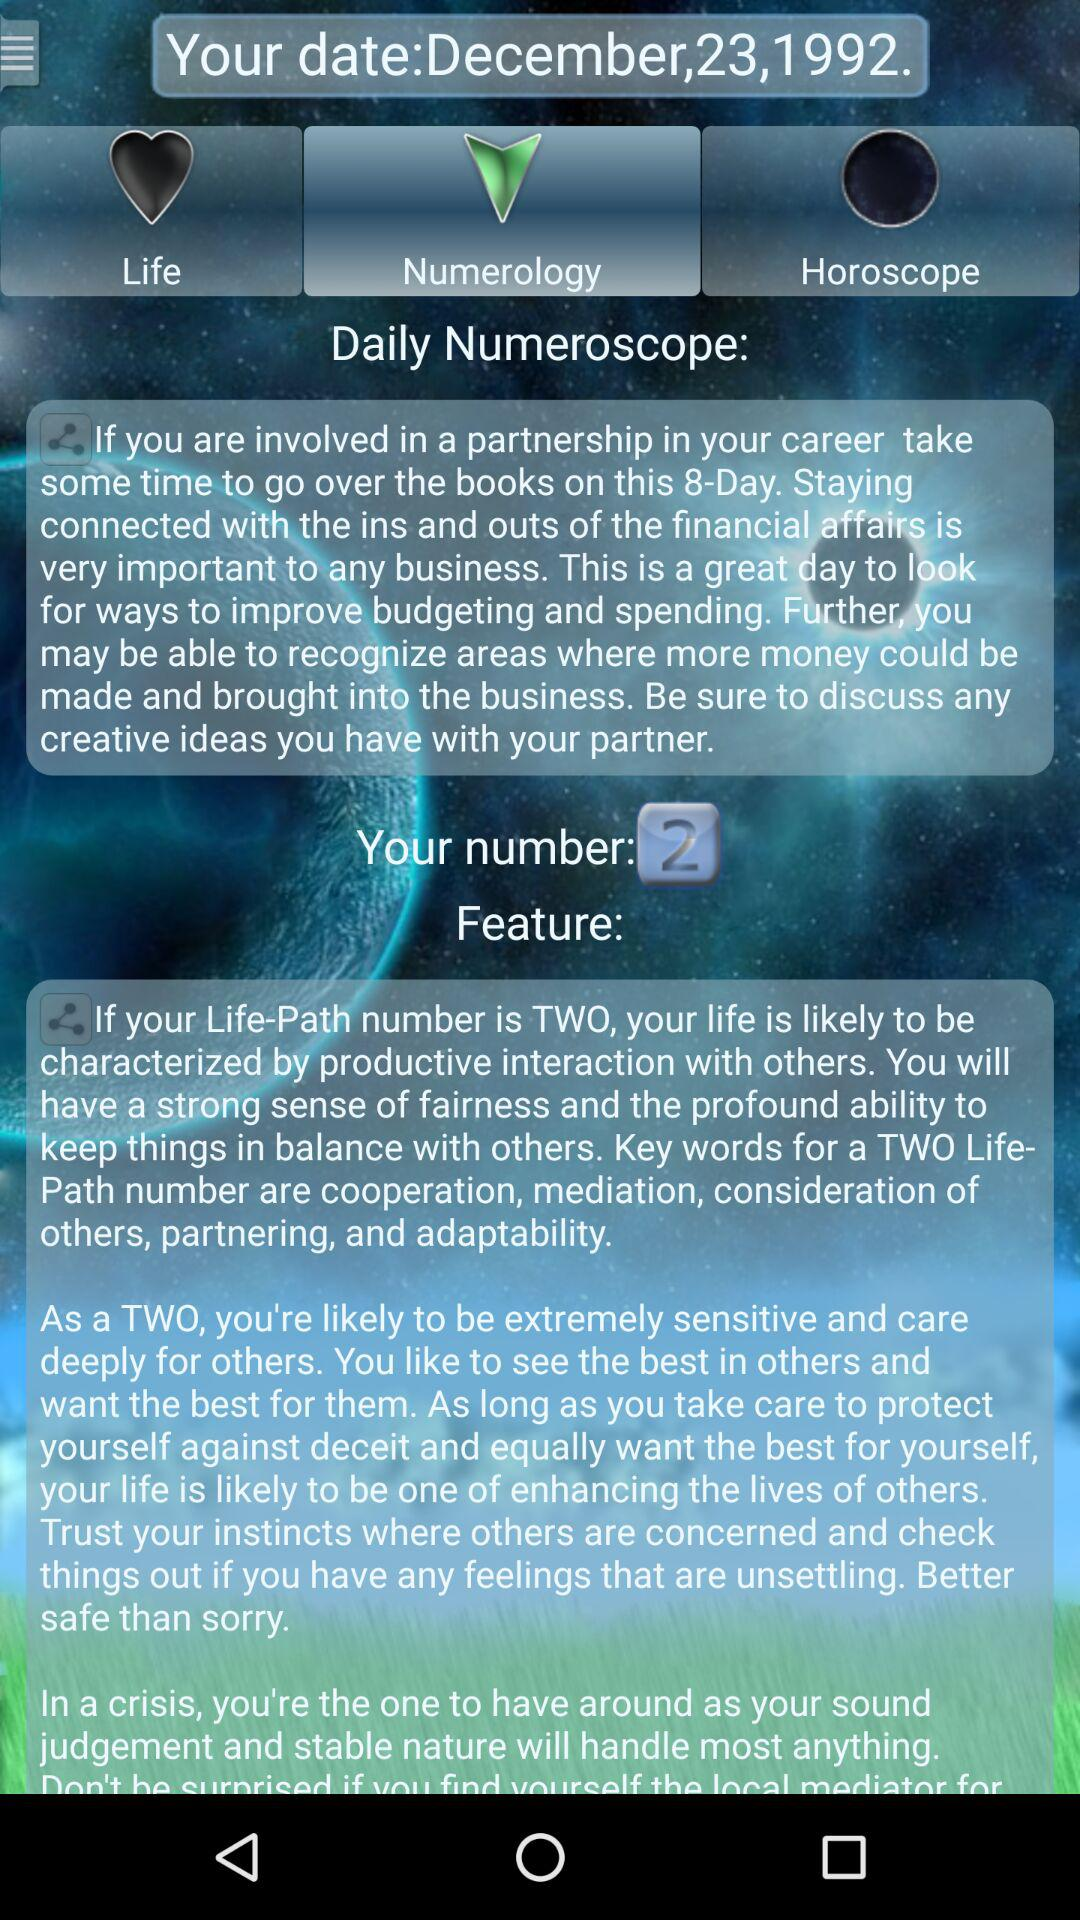What is the date of birth? The date of birth is December 23, 1992. 